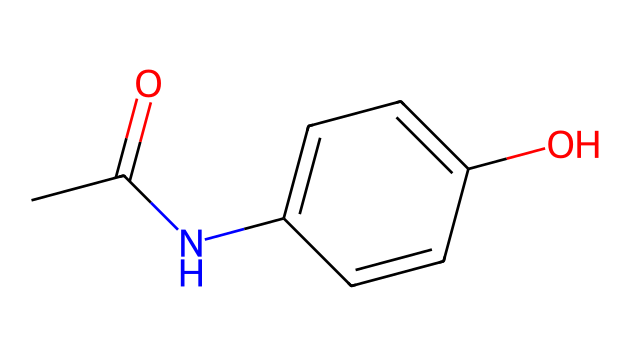What is the molecular formula of this compound? Analyzing the SMILES representation, we can identify the elements involved: there are 8 Carbon (C), 9 Hydrogen (H), 1 Nitrogen (N), and 1 Oxygen (O) atom. Therefore, the molecular formula is C8H9NO.
Answer: C8H9NO How many aromatic rings are present in this structure? By examining the structure described in the SMILES, we can locate a benzene ring indicated by the 'C1=CC...C1' part of the code. Thus, there is one aromatic ring present.
Answer: 1 Which functional groups are present in acetaminophen? The SMILES representation reveals several key features: the -OH group (indicating a phenolic hydroxyl) and the -NH- group (indicating an amide). Both functional groups are characteristic of acetaminophen's structure.
Answer: phenolic hydroxyl and amide Is acetaminophen a polar or non-polar molecule? Due to the presence of both -OH and -NH functional groups, which contribute to hydrogen bonding, as well as a nitrogen atom, acetaminophen exhibits a polar character.
Answer: polar What is the relationship between the benzene ring and the amide group in acetaminophen? The structure shows that the amide group is attached to the benzene ring, making it a para-amide derivative, which is crucial for the drug's biological activity compared to other derivatives.
Answer: para-amide derivative How many total bonds are in the structure of acetaminophen? From the SMILES expression, we discern the multiple bonds: there are a total of 8 single bonds and 2 double bonds, resulting in 10 bonds overall.
Answer: 10 